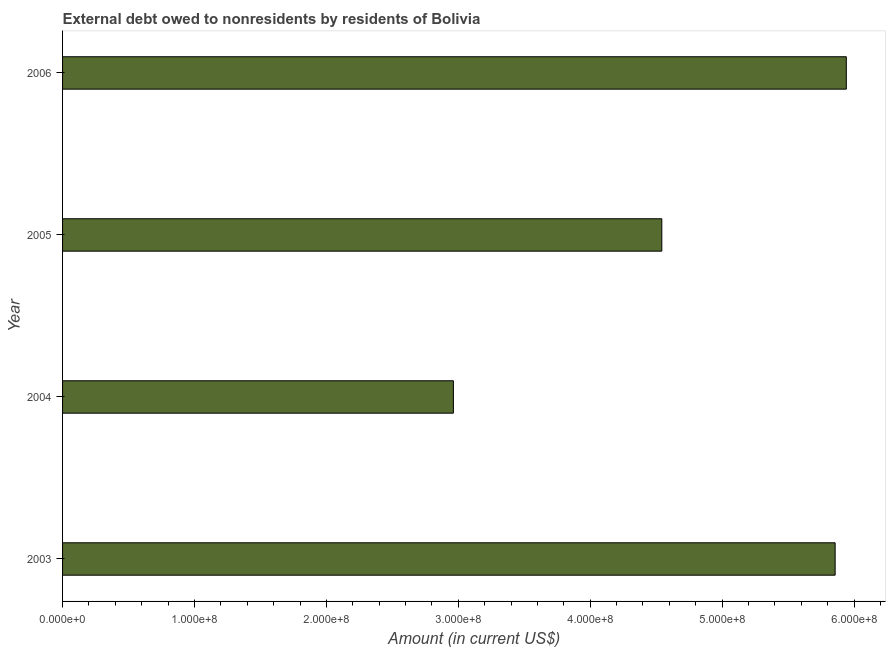What is the title of the graph?
Your answer should be compact. External debt owed to nonresidents by residents of Bolivia. What is the label or title of the X-axis?
Give a very brief answer. Amount (in current US$). What is the label or title of the Y-axis?
Your answer should be compact. Year. What is the debt in 2004?
Offer a very short reply. 2.96e+08. Across all years, what is the maximum debt?
Offer a terse response. 5.94e+08. Across all years, what is the minimum debt?
Offer a terse response. 2.96e+08. In which year was the debt minimum?
Ensure brevity in your answer.  2004. What is the sum of the debt?
Provide a succinct answer. 1.93e+09. What is the difference between the debt in 2005 and 2006?
Your answer should be compact. -1.40e+08. What is the average debt per year?
Keep it short and to the point. 4.83e+08. What is the median debt?
Your answer should be compact. 5.20e+08. In how many years, is the debt greater than 480000000 US$?
Your answer should be compact. 2. Do a majority of the years between 2004 and 2005 (inclusive) have debt greater than 100000000 US$?
Your answer should be compact. Yes. What is the ratio of the debt in 2003 to that in 2005?
Your answer should be compact. 1.29. Is the debt in 2004 less than that in 2006?
Offer a terse response. Yes. What is the difference between the highest and the second highest debt?
Give a very brief answer. 8.47e+06. Is the sum of the debt in 2004 and 2006 greater than the maximum debt across all years?
Provide a short and direct response. Yes. What is the difference between the highest and the lowest debt?
Ensure brevity in your answer.  2.98e+08. In how many years, is the debt greater than the average debt taken over all years?
Your response must be concise. 2. Are all the bars in the graph horizontal?
Offer a very short reply. Yes. What is the Amount (in current US$) of 2003?
Provide a succinct answer. 5.86e+08. What is the Amount (in current US$) of 2004?
Give a very brief answer. 2.96e+08. What is the Amount (in current US$) in 2005?
Ensure brevity in your answer.  4.54e+08. What is the Amount (in current US$) of 2006?
Offer a terse response. 5.94e+08. What is the difference between the Amount (in current US$) in 2003 and 2004?
Make the answer very short. 2.89e+08. What is the difference between the Amount (in current US$) in 2003 and 2005?
Give a very brief answer. 1.31e+08. What is the difference between the Amount (in current US$) in 2003 and 2006?
Keep it short and to the point. -8.47e+06. What is the difference between the Amount (in current US$) in 2004 and 2005?
Your response must be concise. -1.58e+08. What is the difference between the Amount (in current US$) in 2004 and 2006?
Your answer should be very brief. -2.98e+08. What is the difference between the Amount (in current US$) in 2005 and 2006?
Your answer should be very brief. -1.40e+08. What is the ratio of the Amount (in current US$) in 2003 to that in 2004?
Make the answer very short. 1.98. What is the ratio of the Amount (in current US$) in 2003 to that in 2005?
Provide a short and direct response. 1.29. What is the ratio of the Amount (in current US$) in 2004 to that in 2005?
Provide a short and direct response. 0.65. What is the ratio of the Amount (in current US$) in 2004 to that in 2006?
Make the answer very short. 0.5. What is the ratio of the Amount (in current US$) in 2005 to that in 2006?
Your response must be concise. 0.77. 